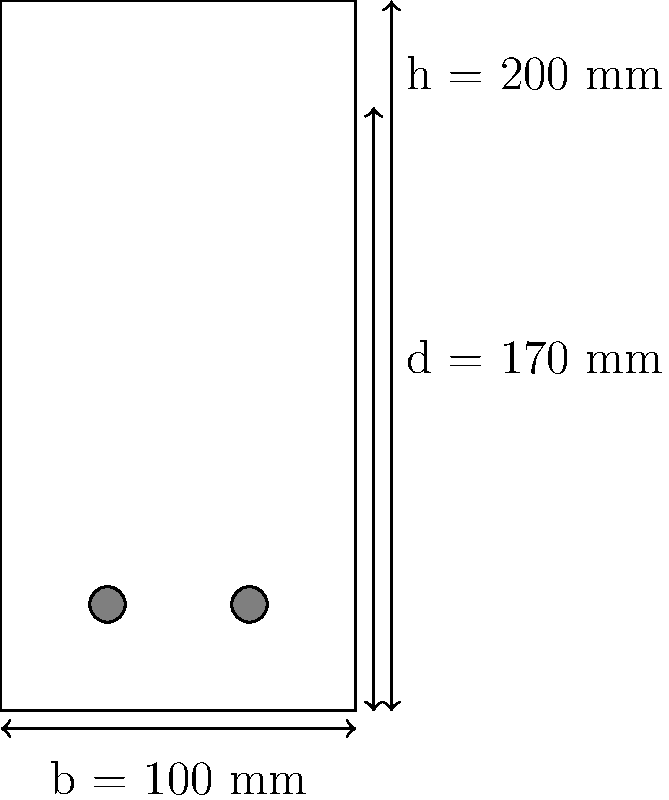For the concrete beam cross-section shown, determine the required area of tension reinforcement (As) if the beam is subjected to a factored moment of 50 kN·m. Given:
- Concrete strength, f'c = 30 MPa
- Steel yield strength, fy = 400 MPa
- Beam width, b = 100 mm
- Effective depth, d = 170 mm
- Overall depth, h = 200 mm
Assume a rectangular stress block and neglect compression reinforcement. To determine the required area of tension reinforcement (As), we'll follow these steps:

1. Calculate the balanced reinforcement ratio (ρb):
   $$\rho_b = \frac{0.85\beta_1f'c}{f_y} \cdot \frac{600}{600+f_y}$$
   Where β1 = 0.85 for f'c ≤ 30 MPa
   $$\rho_b = \frac{0.85 \cdot 0.85 \cdot 30}{400} \cdot \frac{600}{600+400} = 0.0325$$

2. Assume the section is tension-controlled with ρ = 0.75ρb:
   $$\rho = 0.75 \cdot 0.0325 = 0.0244$$

3. Calculate the reinforcement depth ratio (a/d):
   $$\frac{a}{d} = \frac{\rho f_y}{0.85f'c} = \frac{0.0244 \cdot 400}{0.85 \cdot 30} = 0.383$$

4. Calculate the moment resistance factor (ϕ):
   $$\phi = 0.65 + \frac{250\beta_1(d-a)}{d} \leq 0.90$$
   $$\phi = 0.65 + \frac{250 \cdot 0.85(170-0.383 \cdot 170)}{170} = 0.90$$

5. Calculate the required steel area (As):
   $$A_s = \frac{M_u}{\phi f_y d (1-0.5a/d)}$$
   $$A_s = \frac{50 \cdot 10^6}{0.90 \cdot 400 \cdot 170 \cdot (1-0.5 \cdot 0.383)} = 980 \text{ mm}^2$$

6. Check if As > As,min:
   $$A_{s,min} = \frac{0.25\sqrt{f'c}}{f_y}bd = \frac{0.25\sqrt{30}}{400} \cdot 100 \cdot 170 = 58.3 \text{ mm}^2$$
   As > As,min, so use As = 980 mm².
Answer: As = 980 mm² 